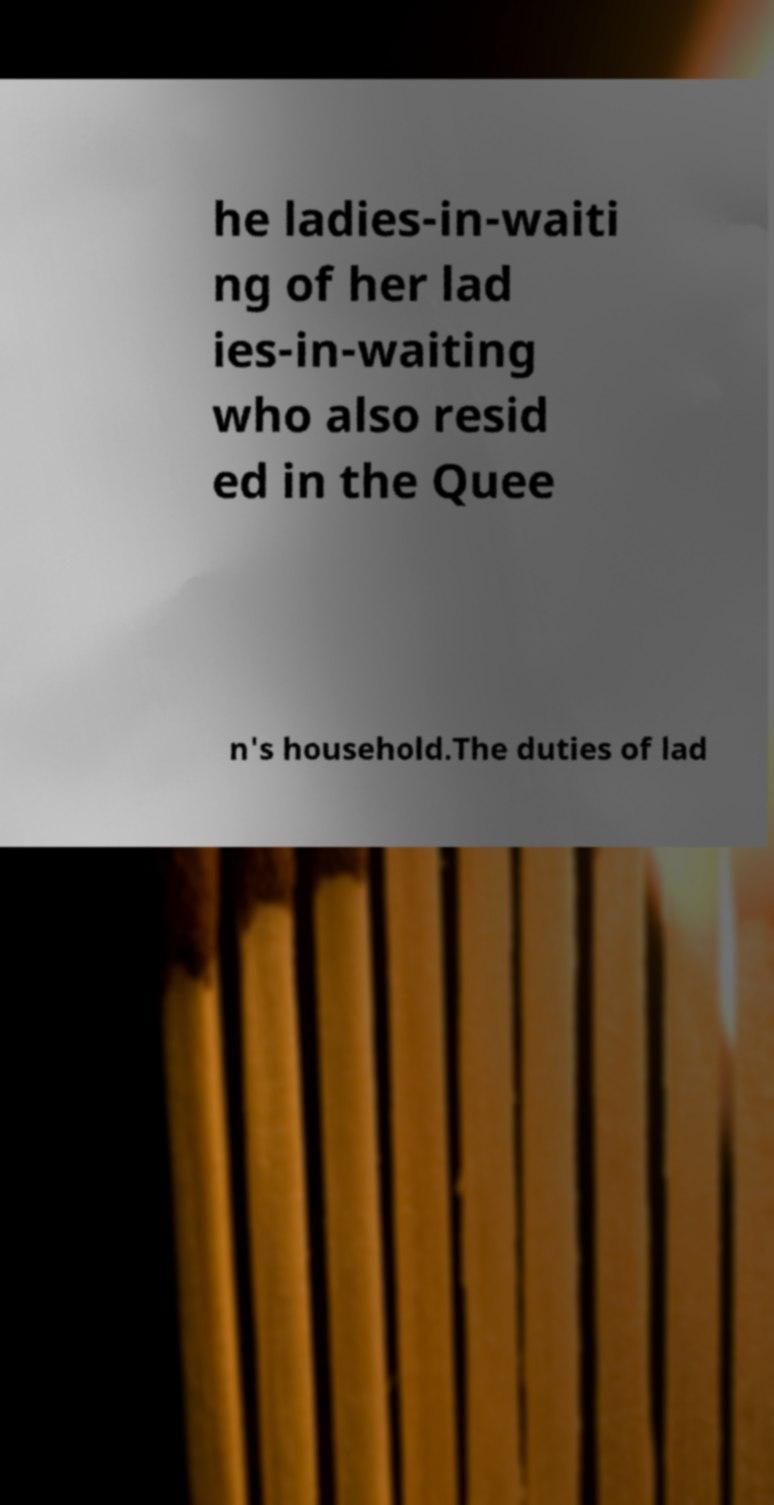I need the written content from this picture converted into text. Can you do that? he ladies-in-waiti ng of her lad ies-in-waiting who also resid ed in the Quee n's household.The duties of lad 